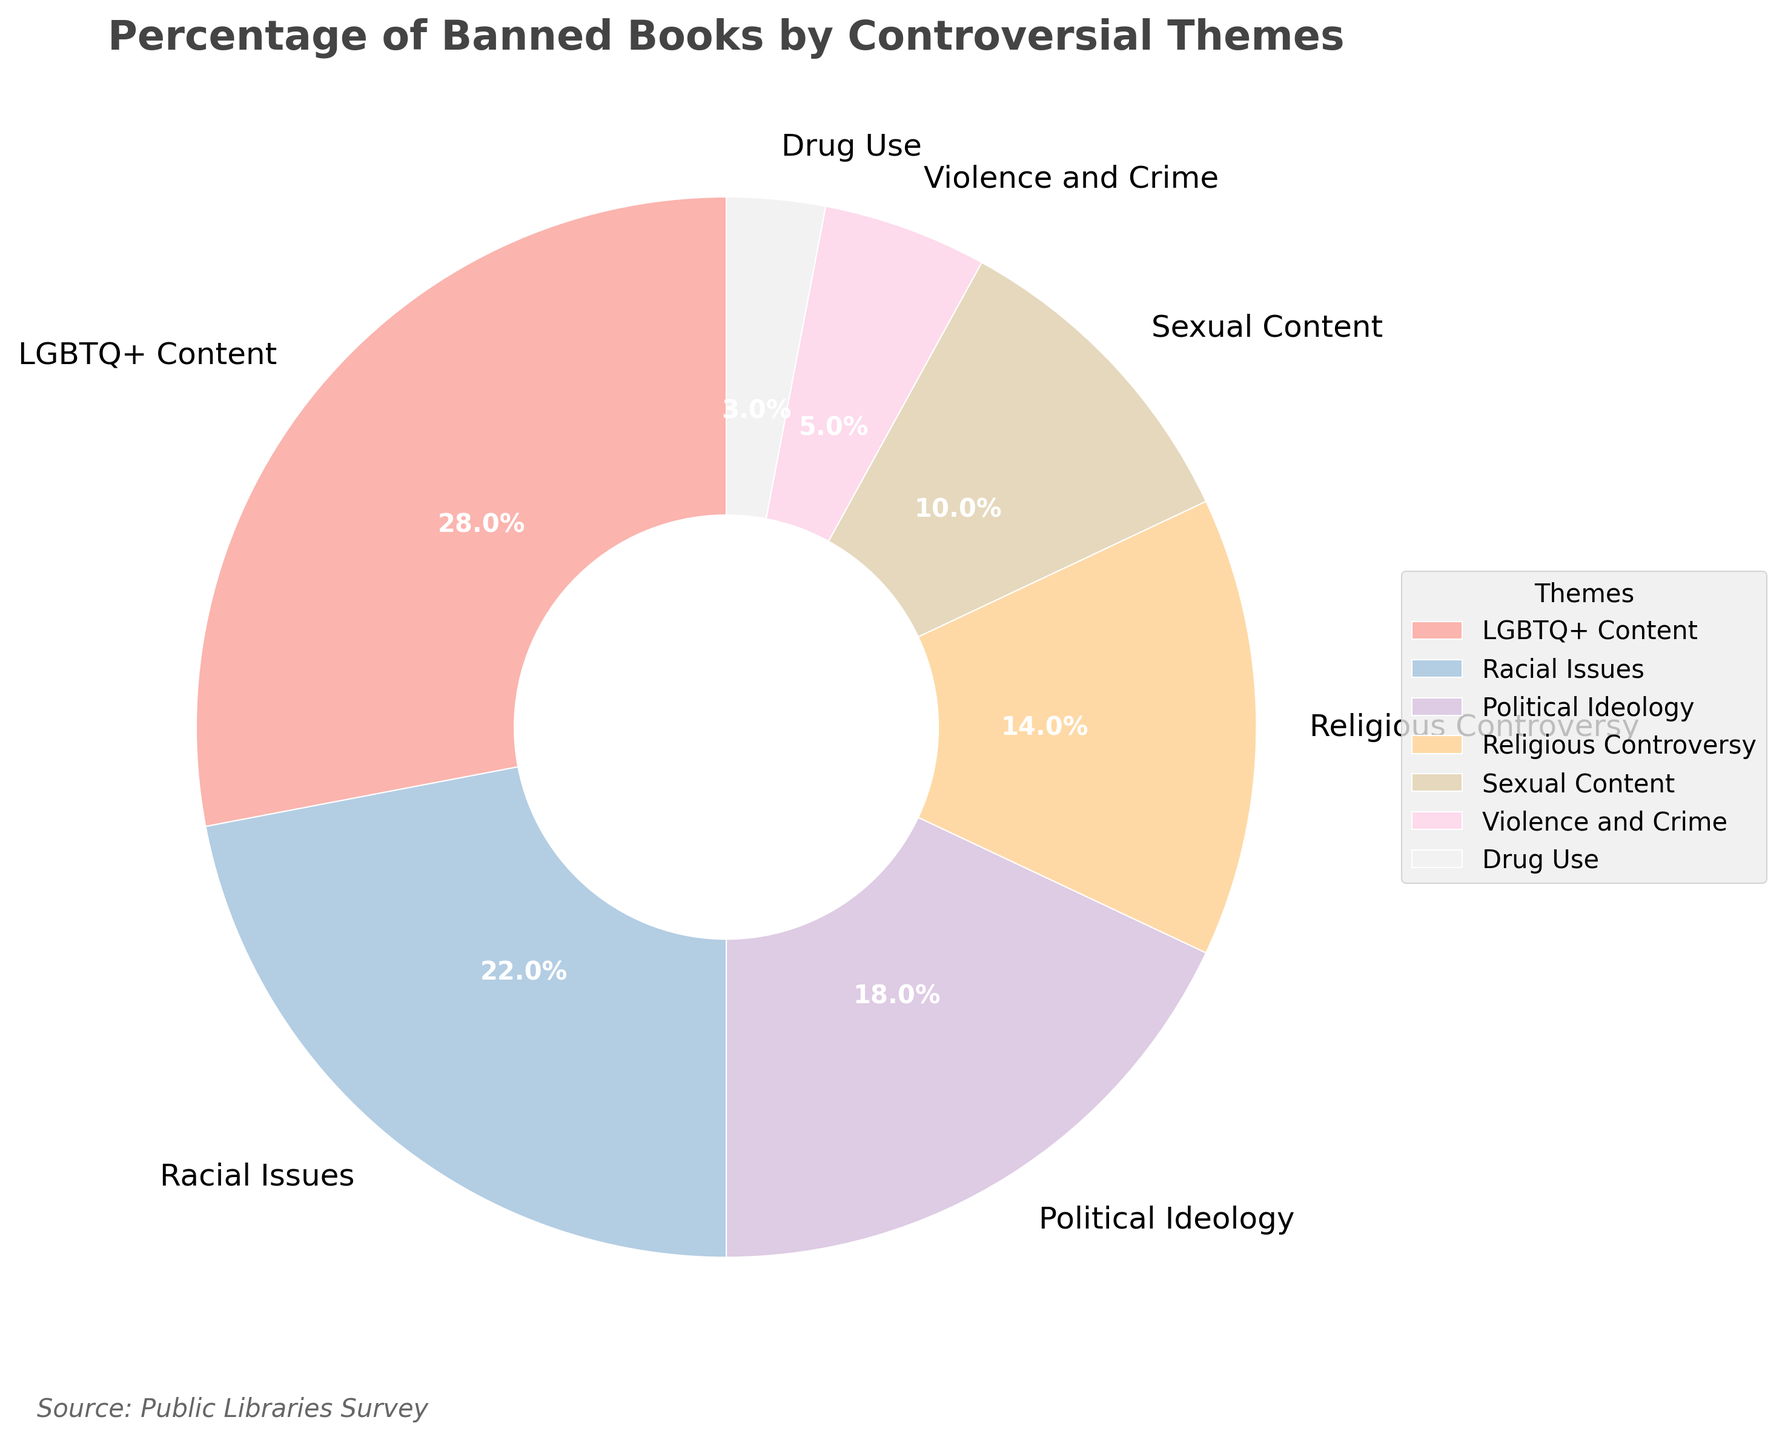Which theme has the highest percentage of banned books? The segment with the highest percentage is the largest one, labeled "LGBTQ+ Content" at 28%.
Answer: LGBTQ+ Content What is the combined percentage of banned books for the themes "Racial Issues" and "Political Ideology"? Sum the percentages for "Racial Issues" (22%) and "Political Ideology" (18%), which gives 22 + 18 = 40.
Answer: 40% Which theme has fewer banned books: "Sexual Content" or "Violence and Crime"? Compare the percentages for "Sexual Content" (10%) and "Violence and Crime" (5%). Since 5% is less than 10%, "Violence and Crime" has fewer banned books.
Answer: Violence and Crime What is the difference in the percentage of banned books between the theme with the highest and the theme with the lowest percentage? The highest percentage is for "LGBTQ+ Content" (28%) and the lowest is for "Drug Use" (3%). The difference is 28 - 3 = 25.
Answer: 25% Which theme segment is colored the darkest, and what percentage does it represent? The darkest color in the Pastel1 palette generally represents the most significant segment, which is "LGBTQ+ Content" with 28%.
Answer: LGBTQ+ Content (28%) What's the average percentage of banned books for all themes combined? Sum all percentages: 28 + 22 + 18 + 14 + 10 + 5 + 3 = 100. There are 7 themes, so the average is 100 / 7 ≈ 14.29.
Answer: 14.29% Is the percentage of banned books for "Sexual Content" more than half the percentage of "Racial Issues"? Half of "Racial Issues" (22%) is 11%. Since "Sexual Content" is 10%, which is less than 11%, it is not more than half.
Answer: No Which themes together constitute exactly half of the total banned books percentage? Find the themes that sum up to 50%. "LGBTQ+ Content" (28%) + "Racial Issues" (22%) together make up 50%.
Answer: LGBTQ+ Content and Racial Issues Which theme represents the smallest percentage of banned books, and by what color is it represented? The smallest segment is for "Drug Use" at 3%. In the Pastel1 color map, lighter colors are assigned sequentially, so it's represented by the lightest color.
Answer: Drug Use (3%) What is the combined percentage of banned books for all themes except "LGBTQ+ Content"? Exclude "LGBTQ+ Content" (28%) percentage and sum the rest: 22 + 18 + 14 + 10 + 5 + 3 = 72.
Answer: 72% 